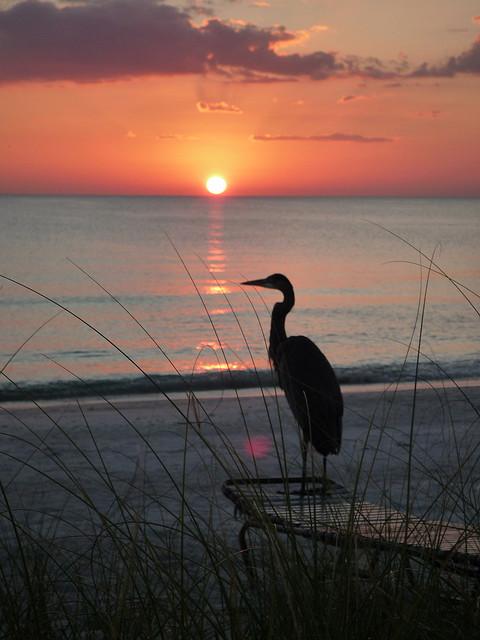Where is the beach bed?
Keep it brief. Under bird. Is the bird standing on a natural or man-made object?
Give a very brief answer. Man made. Was this picture likely to have been taken at noon?
Be succinct. No. 